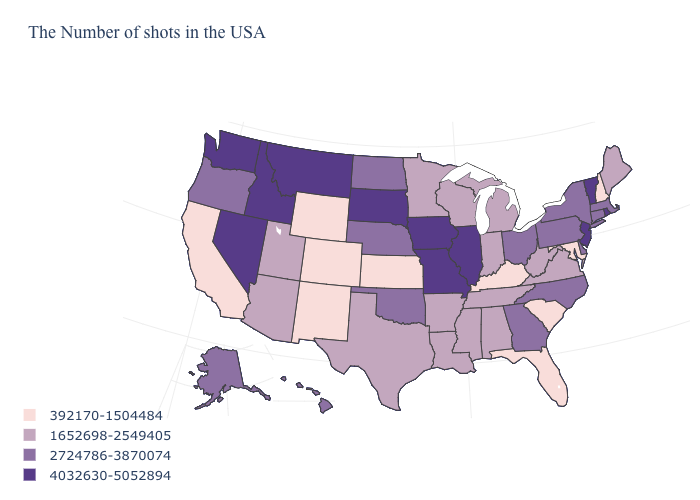Does Nevada have the highest value in the USA?
Give a very brief answer. Yes. Does the first symbol in the legend represent the smallest category?
Short answer required. Yes. What is the value of Illinois?
Keep it brief. 4032630-5052894. What is the highest value in the West ?
Answer briefly. 4032630-5052894. What is the highest value in the USA?
Keep it brief. 4032630-5052894. What is the highest value in the USA?
Give a very brief answer. 4032630-5052894. Among the states that border Kentucky , which have the highest value?
Concise answer only. Illinois, Missouri. What is the value of Maryland?
Short answer required. 392170-1504484. Name the states that have a value in the range 4032630-5052894?
Answer briefly. Rhode Island, Vermont, New Jersey, Illinois, Missouri, Iowa, South Dakota, Montana, Idaho, Nevada, Washington. What is the value of Louisiana?
Keep it brief. 1652698-2549405. What is the value of Utah?
Answer briefly. 1652698-2549405. What is the value of North Dakota?
Keep it brief. 2724786-3870074. Does the first symbol in the legend represent the smallest category?
Write a very short answer. Yes. Does the first symbol in the legend represent the smallest category?
Short answer required. Yes. 